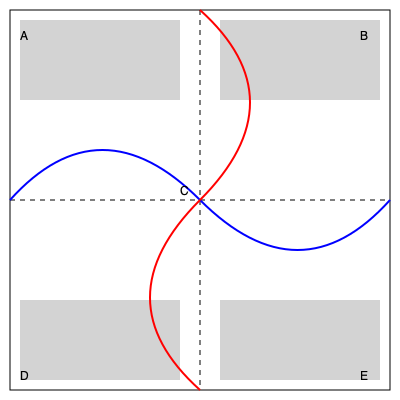Given the floor plan of an underground parking lot above, which traffic flow pattern would be most efficient for minimizing congestion and maximizing throughput? The blue curves represent one option, and the red curves represent another. Consider that areas A, B, D, and E are parking spaces, while C is the central intersection point. To determine the most efficient traffic flow pattern, we need to consider several factors:

1. Conflict points: The number of areas where traffic streams intersect, merge, or diverge.
2. Traffic distribution: How evenly the flow is distributed across the parking lot.
3. Ease of navigation: How intuitive the flow is for drivers.
4. Distance traveled: The total distance vehicles need to travel.

Let's analyze both options:

Blue pattern:
1. Has two main curves that don't intersect at the central point C.
2. Provides a counter-clockwise flow around the entire parking lot.
3. Allows easy access to all parking areas (A, B, D, E) without crossing paths.
4. Minimizes the number of conflict points, as vehicles mostly follow a single direction.

Red pattern:
1. Has two curves that intersect at the central point C.
2. Creates a figure-eight pattern.
3. Requires vehicles to potentially cross paths at point C, increasing the risk of congestion.
4. May lead to confusion for drivers, as the direction changes depending on which quadrant they're in.

Comparing the two:
- The blue pattern has fewer conflict points, reducing the likelihood of congestion.
- The blue pattern provides a more intuitive and consistent flow direction.
- The blue pattern allows for a more even distribution of traffic across all parking areas.
- Both patterns cover similar distances, so this factor is not significantly different.

Given these considerations, the blue pattern is more efficient for minimizing congestion and maximizing throughput. It reduces potential conflicts, provides a clear and consistent flow direction, and allows for easier navigation throughout the parking lot.
Answer: The blue pattern (counter-clockwise flow) 